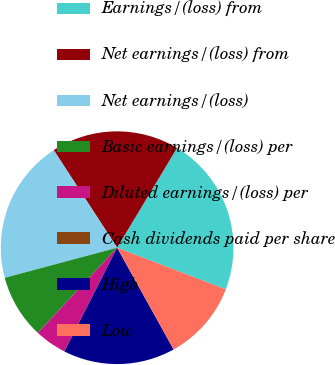Convert chart to OTSL. <chart><loc_0><loc_0><loc_500><loc_500><pie_chart><fcel>Earnings/(loss) from<fcel>Net earnings/(loss) from<fcel>Net earnings/(loss)<fcel>Basic earnings/(loss) per<fcel>Diluted earnings/(loss) per<fcel>Cash dividends paid per share<fcel>High<fcel>Low<nl><fcel>22.22%<fcel>17.78%<fcel>20.0%<fcel>8.89%<fcel>4.45%<fcel>0.01%<fcel>15.55%<fcel>11.11%<nl></chart> 